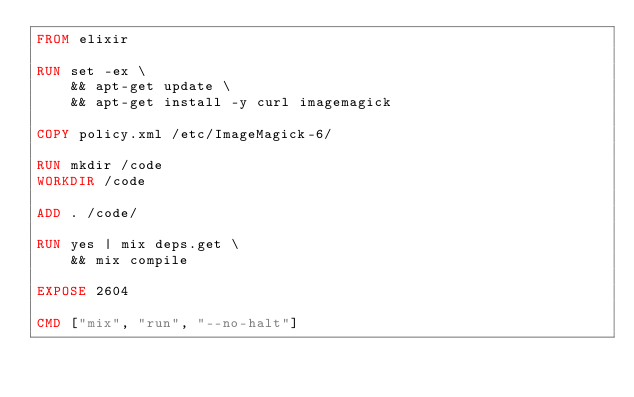<code> <loc_0><loc_0><loc_500><loc_500><_Dockerfile_>FROM elixir

RUN set -ex \
    && apt-get update \
    && apt-get install -y curl imagemagick

COPY policy.xml /etc/ImageMagick-6/

RUN mkdir /code
WORKDIR /code

ADD . /code/

RUN yes | mix deps.get \
    && mix compile

EXPOSE 2604

CMD ["mix", "run", "--no-halt"]
</code> 